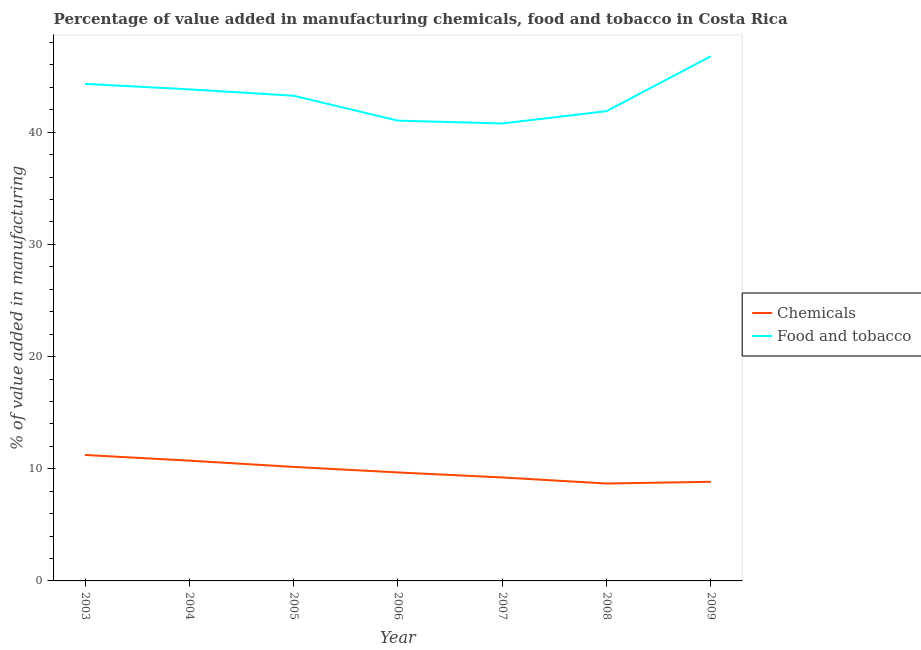Does the line corresponding to value added by  manufacturing chemicals intersect with the line corresponding to value added by manufacturing food and tobacco?
Your answer should be very brief. No. What is the value added by  manufacturing chemicals in 2006?
Keep it short and to the point. 9.67. Across all years, what is the maximum value added by  manufacturing chemicals?
Your answer should be very brief. 11.23. Across all years, what is the minimum value added by  manufacturing chemicals?
Provide a short and direct response. 8.68. What is the total value added by  manufacturing chemicals in the graph?
Your answer should be compact. 68.53. What is the difference between the value added by manufacturing food and tobacco in 2005 and that in 2009?
Your response must be concise. -3.52. What is the difference between the value added by  manufacturing chemicals in 2008 and the value added by manufacturing food and tobacco in 2007?
Keep it short and to the point. -32.1. What is the average value added by manufacturing food and tobacco per year?
Your response must be concise. 43.13. In the year 2008, what is the difference between the value added by manufacturing food and tobacco and value added by  manufacturing chemicals?
Your response must be concise. 33.2. What is the ratio of the value added by  manufacturing chemicals in 2005 to that in 2009?
Ensure brevity in your answer.  1.15. Is the value added by  manufacturing chemicals in 2005 less than that in 2006?
Your answer should be very brief. No. Is the difference between the value added by manufacturing food and tobacco in 2007 and 2009 greater than the difference between the value added by  manufacturing chemicals in 2007 and 2009?
Ensure brevity in your answer.  No. What is the difference between the highest and the second highest value added by  manufacturing chemicals?
Make the answer very short. 0.51. What is the difference between the highest and the lowest value added by manufacturing food and tobacco?
Offer a very short reply. 5.99. In how many years, is the value added by  manufacturing chemicals greater than the average value added by  manufacturing chemicals taken over all years?
Provide a short and direct response. 3. Is the sum of the value added by  manufacturing chemicals in 2005 and 2008 greater than the maximum value added by manufacturing food and tobacco across all years?
Offer a very short reply. No. Is the value added by  manufacturing chemicals strictly greater than the value added by manufacturing food and tobacco over the years?
Keep it short and to the point. No. Is the value added by  manufacturing chemicals strictly less than the value added by manufacturing food and tobacco over the years?
Keep it short and to the point. Yes. What is the difference between two consecutive major ticks on the Y-axis?
Your response must be concise. 10. Are the values on the major ticks of Y-axis written in scientific E-notation?
Provide a short and direct response. No. What is the title of the graph?
Keep it short and to the point. Percentage of value added in manufacturing chemicals, food and tobacco in Costa Rica. Does "GDP" appear as one of the legend labels in the graph?
Your answer should be compact. No. What is the label or title of the Y-axis?
Provide a succinct answer. % of value added in manufacturing. What is the % of value added in manufacturing in Chemicals in 2003?
Offer a very short reply. 11.23. What is the % of value added in manufacturing in Food and tobacco in 2003?
Keep it short and to the point. 44.31. What is the % of value added in manufacturing of Chemicals in 2004?
Give a very brief answer. 10.72. What is the % of value added in manufacturing in Food and tobacco in 2004?
Your response must be concise. 43.83. What is the % of value added in manufacturing of Chemicals in 2005?
Make the answer very short. 10.16. What is the % of value added in manufacturing in Food and tobacco in 2005?
Your response must be concise. 43.26. What is the % of value added in manufacturing of Chemicals in 2006?
Your answer should be compact. 9.67. What is the % of value added in manufacturing of Food and tobacco in 2006?
Your response must be concise. 41.04. What is the % of value added in manufacturing of Chemicals in 2007?
Your answer should be compact. 9.22. What is the % of value added in manufacturing of Food and tobacco in 2007?
Your response must be concise. 40.78. What is the % of value added in manufacturing in Chemicals in 2008?
Give a very brief answer. 8.68. What is the % of value added in manufacturing of Food and tobacco in 2008?
Your answer should be very brief. 41.88. What is the % of value added in manufacturing of Chemicals in 2009?
Provide a short and direct response. 8.84. What is the % of value added in manufacturing of Food and tobacco in 2009?
Offer a terse response. 46.78. Across all years, what is the maximum % of value added in manufacturing in Chemicals?
Provide a short and direct response. 11.23. Across all years, what is the maximum % of value added in manufacturing of Food and tobacco?
Offer a very short reply. 46.78. Across all years, what is the minimum % of value added in manufacturing in Chemicals?
Your response must be concise. 8.68. Across all years, what is the minimum % of value added in manufacturing of Food and tobacco?
Give a very brief answer. 40.78. What is the total % of value added in manufacturing in Chemicals in the graph?
Offer a terse response. 68.53. What is the total % of value added in manufacturing of Food and tobacco in the graph?
Keep it short and to the point. 301.88. What is the difference between the % of value added in manufacturing of Chemicals in 2003 and that in 2004?
Offer a very short reply. 0.51. What is the difference between the % of value added in manufacturing of Food and tobacco in 2003 and that in 2004?
Keep it short and to the point. 0.49. What is the difference between the % of value added in manufacturing in Chemicals in 2003 and that in 2005?
Give a very brief answer. 1.06. What is the difference between the % of value added in manufacturing of Food and tobacco in 2003 and that in 2005?
Keep it short and to the point. 1.06. What is the difference between the % of value added in manufacturing in Chemicals in 2003 and that in 2006?
Make the answer very short. 1.56. What is the difference between the % of value added in manufacturing of Food and tobacco in 2003 and that in 2006?
Give a very brief answer. 3.28. What is the difference between the % of value added in manufacturing of Chemicals in 2003 and that in 2007?
Offer a terse response. 2. What is the difference between the % of value added in manufacturing of Food and tobacco in 2003 and that in 2007?
Offer a very short reply. 3.53. What is the difference between the % of value added in manufacturing of Chemicals in 2003 and that in 2008?
Ensure brevity in your answer.  2.54. What is the difference between the % of value added in manufacturing in Food and tobacco in 2003 and that in 2008?
Give a very brief answer. 2.43. What is the difference between the % of value added in manufacturing of Chemicals in 2003 and that in 2009?
Keep it short and to the point. 2.39. What is the difference between the % of value added in manufacturing in Food and tobacco in 2003 and that in 2009?
Provide a succinct answer. -2.46. What is the difference between the % of value added in manufacturing of Chemicals in 2004 and that in 2005?
Your answer should be compact. 0.56. What is the difference between the % of value added in manufacturing of Food and tobacco in 2004 and that in 2005?
Your answer should be compact. 0.57. What is the difference between the % of value added in manufacturing in Chemicals in 2004 and that in 2006?
Make the answer very short. 1.05. What is the difference between the % of value added in manufacturing of Food and tobacco in 2004 and that in 2006?
Your answer should be compact. 2.79. What is the difference between the % of value added in manufacturing in Chemicals in 2004 and that in 2007?
Ensure brevity in your answer.  1.5. What is the difference between the % of value added in manufacturing in Food and tobacco in 2004 and that in 2007?
Offer a very short reply. 3.04. What is the difference between the % of value added in manufacturing of Chemicals in 2004 and that in 2008?
Keep it short and to the point. 2.04. What is the difference between the % of value added in manufacturing of Food and tobacco in 2004 and that in 2008?
Provide a succinct answer. 1.95. What is the difference between the % of value added in manufacturing of Chemicals in 2004 and that in 2009?
Give a very brief answer. 1.89. What is the difference between the % of value added in manufacturing of Food and tobacco in 2004 and that in 2009?
Provide a succinct answer. -2.95. What is the difference between the % of value added in manufacturing in Chemicals in 2005 and that in 2006?
Your response must be concise. 0.49. What is the difference between the % of value added in manufacturing in Food and tobacco in 2005 and that in 2006?
Keep it short and to the point. 2.22. What is the difference between the % of value added in manufacturing of Chemicals in 2005 and that in 2007?
Offer a terse response. 0.94. What is the difference between the % of value added in manufacturing of Food and tobacco in 2005 and that in 2007?
Give a very brief answer. 2.47. What is the difference between the % of value added in manufacturing in Chemicals in 2005 and that in 2008?
Make the answer very short. 1.48. What is the difference between the % of value added in manufacturing in Food and tobacco in 2005 and that in 2008?
Provide a short and direct response. 1.38. What is the difference between the % of value added in manufacturing of Chemicals in 2005 and that in 2009?
Ensure brevity in your answer.  1.33. What is the difference between the % of value added in manufacturing in Food and tobacco in 2005 and that in 2009?
Give a very brief answer. -3.52. What is the difference between the % of value added in manufacturing of Chemicals in 2006 and that in 2007?
Your answer should be compact. 0.45. What is the difference between the % of value added in manufacturing of Food and tobacco in 2006 and that in 2007?
Make the answer very short. 0.25. What is the difference between the % of value added in manufacturing of Chemicals in 2006 and that in 2008?
Your answer should be very brief. 0.99. What is the difference between the % of value added in manufacturing of Food and tobacco in 2006 and that in 2008?
Provide a succinct answer. -0.84. What is the difference between the % of value added in manufacturing in Chemicals in 2006 and that in 2009?
Your answer should be very brief. 0.84. What is the difference between the % of value added in manufacturing in Food and tobacco in 2006 and that in 2009?
Offer a very short reply. -5.74. What is the difference between the % of value added in manufacturing of Chemicals in 2007 and that in 2008?
Your response must be concise. 0.54. What is the difference between the % of value added in manufacturing in Food and tobacco in 2007 and that in 2008?
Your answer should be compact. -1.1. What is the difference between the % of value added in manufacturing in Chemicals in 2007 and that in 2009?
Keep it short and to the point. 0.39. What is the difference between the % of value added in manufacturing in Food and tobacco in 2007 and that in 2009?
Provide a short and direct response. -5.99. What is the difference between the % of value added in manufacturing in Chemicals in 2008 and that in 2009?
Give a very brief answer. -0.15. What is the difference between the % of value added in manufacturing in Food and tobacco in 2008 and that in 2009?
Your response must be concise. -4.9. What is the difference between the % of value added in manufacturing in Chemicals in 2003 and the % of value added in manufacturing in Food and tobacco in 2004?
Offer a very short reply. -32.6. What is the difference between the % of value added in manufacturing in Chemicals in 2003 and the % of value added in manufacturing in Food and tobacco in 2005?
Provide a short and direct response. -32.03. What is the difference between the % of value added in manufacturing of Chemicals in 2003 and the % of value added in manufacturing of Food and tobacco in 2006?
Provide a succinct answer. -29.81. What is the difference between the % of value added in manufacturing of Chemicals in 2003 and the % of value added in manufacturing of Food and tobacco in 2007?
Ensure brevity in your answer.  -29.56. What is the difference between the % of value added in manufacturing in Chemicals in 2003 and the % of value added in manufacturing in Food and tobacco in 2008?
Give a very brief answer. -30.65. What is the difference between the % of value added in manufacturing in Chemicals in 2003 and the % of value added in manufacturing in Food and tobacco in 2009?
Make the answer very short. -35.55. What is the difference between the % of value added in manufacturing of Chemicals in 2004 and the % of value added in manufacturing of Food and tobacco in 2005?
Provide a succinct answer. -32.53. What is the difference between the % of value added in manufacturing in Chemicals in 2004 and the % of value added in manufacturing in Food and tobacco in 2006?
Your response must be concise. -30.31. What is the difference between the % of value added in manufacturing of Chemicals in 2004 and the % of value added in manufacturing of Food and tobacco in 2007?
Keep it short and to the point. -30.06. What is the difference between the % of value added in manufacturing in Chemicals in 2004 and the % of value added in manufacturing in Food and tobacco in 2008?
Your answer should be very brief. -31.16. What is the difference between the % of value added in manufacturing in Chemicals in 2004 and the % of value added in manufacturing in Food and tobacco in 2009?
Make the answer very short. -36.05. What is the difference between the % of value added in manufacturing in Chemicals in 2005 and the % of value added in manufacturing in Food and tobacco in 2006?
Your response must be concise. -30.87. What is the difference between the % of value added in manufacturing in Chemicals in 2005 and the % of value added in manufacturing in Food and tobacco in 2007?
Provide a succinct answer. -30.62. What is the difference between the % of value added in manufacturing in Chemicals in 2005 and the % of value added in manufacturing in Food and tobacco in 2008?
Your answer should be compact. -31.72. What is the difference between the % of value added in manufacturing in Chemicals in 2005 and the % of value added in manufacturing in Food and tobacco in 2009?
Offer a very short reply. -36.61. What is the difference between the % of value added in manufacturing in Chemicals in 2006 and the % of value added in manufacturing in Food and tobacco in 2007?
Your response must be concise. -31.11. What is the difference between the % of value added in manufacturing in Chemicals in 2006 and the % of value added in manufacturing in Food and tobacco in 2008?
Your answer should be compact. -32.21. What is the difference between the % of value added in manufacturing in Chemicals in 2006 and the % of value added in manufacturing in Food and tobacco in 2009?
Your response must be concise. -37.11. What is the difference between the % of value added in manufacturing in Chemicals in 2007 and the % of value added in manufacturing in Food and tobacco in 2008?
Provide a short and direct response. -32.66. What is the difference between the % of value added in manufacturing of Chemicals in 2007 and the % of value added in manufacturing of Food and tobacco in 2009?
Offer a very short reply. -37.55. What is the difference between the % of value added in manufacturing in Chemicals in 2008 and the % of value added in manufacturing in Food and tobacco in 2009?
Provide a short and direct response. -38.09. What is the average % of value added in manufacturing of Chemicals per year?
Make the answer very short. 9.79. What is the average % of value added in manufacturing in Food and tobacco per year?
Offer a terse response. 43.13. In the year 2003, what is the difference between the % of value added in manufacturing in Chemicals and % of value added in manufacturing in Food and tobacco?
Ensure brevity in your answer.  -33.08. In the year 2004, what is the difference between the % of value added in manufacturing in Chemicals and % of value added in manufacturing in Food and tobacco?
Give a very brief answer. -33.1. In the year 2005, what is the difference between the % of value added in manufacturing of Chemicals and % of value added in manufacturing of Food and tobacco?
Give a very brief answer. -33.09. In the year 2006, what is the difference between the % of value added in manufacturing of Chemicals and % of value added in manufacturing of Food and tobacco?
Offer a terse response. -31.36. In the year 2007, what is the difference between the % of value added in manufacturing of Chemicals and % of value added in manufacturing of Food and tobacco?
Your response must be concise. -31.56. In the year 2008, what is the difference between the % of value added in manufacturing in Chemicals and % of value added in manufacturing in Food and tobacco?
Offer a terse response. -33.2. In the year 2009, what is the difference between the % of value added in manufacturing in Chemicals and % of value added in manufacturing in Food and tobacco?
Provide a succinct answer. -37.94. What is the ratio of the % of value added in manufacturing of Chemicals in 2003 to that in 2004?
Your answer should be very brief. 1.05. What is the ratio of the % of value added in manufacturing of Food and tobacco in 2003 to that in 2004?
Offer a terse response. 1.01. What is the ratio of the % of value added in manufacturing in Chemicals in 2003 to that in 2005?
Your answer should be compact. 1.1. What is the ratio of the % of value added in manufacturing in Food and tobacco in 2003 to that in 2005?
Give a very brief answer. 1.02. What is the ratio of the % of value added in manufacturing of Chemicals in 2003 to that in 2006?
Your answer should be very brief. 1.16. What is the ratio of the % of value added in manufacturing of Food and tobacco in 2003 to that in 2006?
Your response must be concise. 1.08. What is the ratio of the % of value added in manufacturing in Chemicals in 2003 to that in 2007?
Provide a succinct answer. 1.22. What is the ratio of the % of value added in manufacturing in Food and tobacco in 2003 to that in 2007?
Keep it short and to the point. 1.09. What is the ratio of the % of value added in manufacturing of Chemicals in 2003 to that in 2008?
Your answer should be very brief. 1.29. What is the ratio of the % of value added in manufacturing of Food and tobacco in 2003 to that in 2008?
Your answer should be very brief. 1.06. What is the ratio of the % of value added in manufacturing of Chemicals in 2003 to that in 2009?
Offer a very short reply. 1.27. What is the ratio of the % of value added in manufacturing of Food and tobacco in 2003 to that in 2009?
Offer a very short reply. 0.95. What is the ratio of the % of value added in manufacturing in Chemicals in 2004 to that in 2005?
Offer a very short reply. 1.05. What is the ratio of the % of value added in manufacturing of Food and tobacco in 2004 to that in 2005?
Keep it short and to the point. 1.01. What is the ratio of the % of value added in manufacturing of Chemicals in 2004 to that in 2006?
Keep it short and to the point. 1.11. What is the ratio of the % of value added in manufacturing in Food and tobacco in 2004 to that in 2006?
Offer a terse response. 1.07. What is the ratio of the % of value added in manufacturing of Chemicals in 2004 to that in 2007?
Keep it short and to the point. 1.16. What is the ratio of the % of value added in manufacturing of Food and tobacco in 2004 to that in 2007?
Your answer should be very brief. 1.07. What is the ratio of the % of value added in manufacturing of Chemicals in 2004 to that in 2008?
Give a very brief answer. 1.23. What is the ratio of the % of value added in manufacturing of Food and tobacco in 2004 to that in 2008?
Offer a very short reply. 1.05. What is the ratio of the % of value added in manufacturing of Chemicals in 2004 to that in 2009?
Your answer should be very brief. 1.21. What is the ratio of the % of value added in manufacturing in Food and tobacco in 2004 to that in 2009?
Your answer should be very brief. 0.94. What is the ratio of the % of value added in manufacturing in Chemicals in 2005 to that in 2006?
Keep it short and to the point. 1.05. What is the ratio of the % of value added in manufacturing of Food and tobacco in 2005 to that in 2006?
Provide a short and direct response. 1.05. What is the ratio of the % of value added in manufacturing in Chemicals in 2005 to that in 2007?
Provide a short and direct response. 1.1. What is the ratio of the % of value added in manufacturing of Food and tobacco in 2005 to that in 2007?
Provide a short and direct response. 1.06. What is the ratio of the % of value added in manufacturing in Chemicals in 2005 to that in 2008?
Keep it short and to the point. 1.17. What is the ratio of the % of value added in manufacturing in Food and tobacco in 2005 to that in 2008?
Make the answer very short. 1.03. What is the ratio of the % of value added in manufacturing in Chemicals in 2005 to that in 2009?
Your answer should be very brief. 1.15. What is the ratio of the % of value added in manufacturing of Food and tobacco in 2005 to that in 2009?
Provide a short and direct response. 0.92. What is the ratio of the % of value added in manufacturing of Chemicals in 2006 to that in 2007?
Your answer should be compact. 1.05. What is the ratio of the % of value added in manufacturing of Chemicals in 2006 to that in 2008?
Your answer should be very brief. 1.11. What is the ratio of the % of value added in manufacturing in Food and tobacco in 2006 to that in 2008?
Give a very brief answer. 0.98. What is the ratio of the % of value added in manufacturing in Chemicals in 2006 to that in 2009?
Make the answer very short. 1.09. What is the ratio of the % of value added in manufacturing in Food and tobacco in 2006 to that in 2009?
Provide a short and direct response. 0.88. What is the ratio of the % of value added in manufacturing of Chemicals in 2007 to that in 2008?
Your answer should be compact. 1.06. What is the ratio of the % of value added in manufacturing in Food and tobacco in 2007 to that in 2008?
Your answer should be compact. 0.97. What is the ratio of the % of value added in manufacturing of Chemicals in 2007 to that in 2009?
Your answer should be very brief. 1.04. What is the ratio of the % of value added in manufacturing of Food and tobacco in 2007 to that in 2009?
Provide a short and direct response. 0.87. What is the ratio of the % of value added in manufacturing of Chemicals in 2008 to that in 2009?
Ensure brevity in your answer.  0.98. What is the ratio of the % of value added in manufacturing in Food and tobacco in 2008 to that in 2009?
Provide a short and direct response. 0.9. What is the difference between the highest and the second highest % of value added in manufacturing in Chemicals?
Your response must be concise. 0.51. What is the difference between the highest and the second highest % of value added in manufacturing in Food and tobacco?
Provide a short and direct response. 2.46. What is the difference between the highest and the lowest % of value added in manufacturing in Chemicals?
Give a very brief answer. 2.54. What is the difference between the highest and the lowest % of value added in manufacturing in Food and tobacco?
Provide a short and direct response. 5.99. 